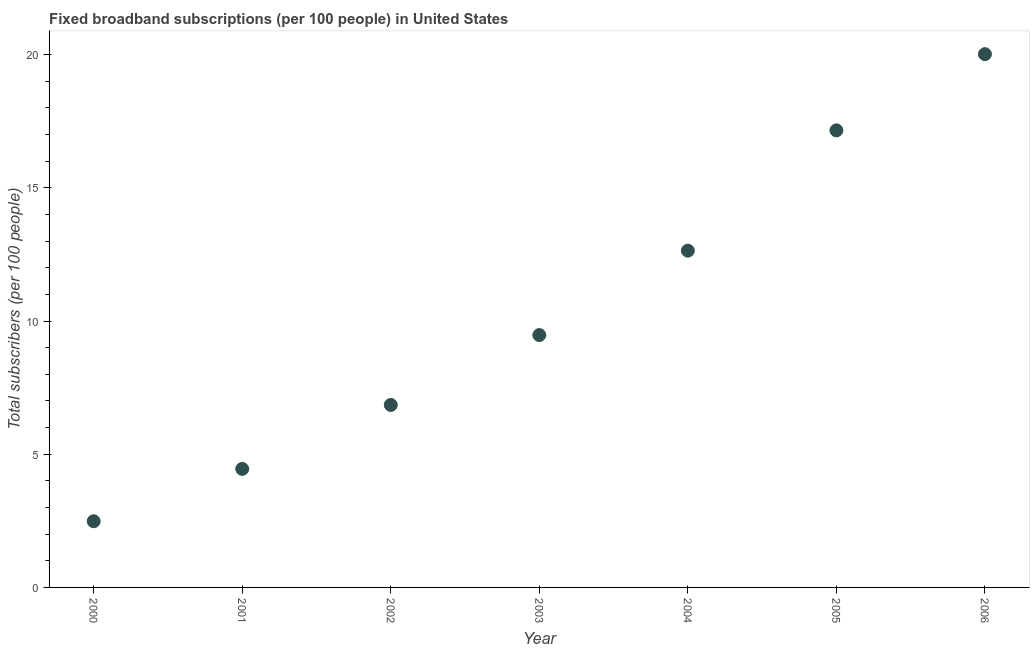What is the total number of fixed broadband subscriptions in 2002?
Offer a very short reply. 6.85. Across all years, what is the maximum total number of fixed broadband subscriptions?
Your answer should be compact. 20.02. Across all years, what is the minimum total number of fixed broadband subscriptions?
Your answer should be very brief. 2.48. What is the sum of the total number of fixed broadband subscriptions?
Give a very brief answer. 73.07. What is the difference between the total number of fixed broadband subscriptions in 2002 and 2005?
Offer a very short reply. -10.31. What is the average total number of fixed broadband subscriptions per year?
Provide a short and direct response. 10.44. What is the median total number of fixed broadband subscriptions?
Provide a short and direct response. 9.47. In how many years, is the total number of fixed broadband subscriptions greater than 10 ?
Keep it short and to the point. 3. What is the ratio of the total number of fixed broadband subscriptions in 2000 to that in 2003?
Make the answer very short. 0.26. Is the difference between the total number of fixed broadband subscriptions in 2004 and 2005 greater than the difference between any two years?
Provide a short and direct response. No. What is the difference between the highest and the second highest total number of fixed broadband subscriptions?
Make the answer very short. 2.86. Is the sum of the total number of fixed broadband subscriptions in 2000 and 2005 greater than the maximum total number of fixed broadband subscriptions across all years?
Make the answer very short. No. What is the difference between the highest and the lowest total number of fixed broadband subscriptions?
Offer a very short reply. 17.53. In how many years, is the total number of fixed broadband subscriptions greater than the average total number of fixed broadband subscriptions taken over all years?
Give a very brief answer. 3. Does the total number of fixed broadband subscriptions monotonically increase over the years?
Keep it short and to the point. Yes. Does the graph contain any zero values?
Your answer should be very brief. No. What is the title of the graph?
Provide a short and direct response. Fixed broadband subscriptions (per 100 people) in United States. What is the label or title of the X-axis?
Your answer should be compact. Year. What is the label or title of the Y-axis?
Offer a very short reply. Total subscribers (per 100 people). What is the Total subscribers (per 100 people) in 2000?
Keep it short and to the point. 2.48. What is the Total subscribers (per 100 people) in 2001?
Provide a succinct answer. 4.45. What is the Total subscribers (per 100 people) in 2002?
Offer a terse response. 6.85. What is the Total subscribers (per 100 people) in 2003?
Give a very brief answer. 9.47. What is the Total subscribers (per 100 people) in 2004?
Your answer should be compact. 12.64. What is the Total subscribers (per 100 people) in 2005?
Make the answer very short. 17.16. What is the Total subscribers (per 100 people) in 2006?
Ensure brevity in your answer.  20.02. What is the difference between the Total subscribers (per 100 people) in 2000 and 2001?
Your answer should be very brief. -1.96. What is the difference between the Total subscribers (per 100 people) in 2000 and 2002?
Keep it short and to the point. -4.37. What is the difference between the Total subscribers (per 100 people) in 2000 and 2003?
Provide a succinct answer. -6.99. What is the difference between the Total subscribers (per 100 people) in 2000 and 2004?
Your answer should be very brief. -10.16. What is the difference between the Total subscribers (per 100 people) in 2000 and 2005?
Your answer should be compact. -14.67. What is the difference between the Total subscribers (per 100 people) in 2000 and 2006?
Ensure brevity in your answer.  -17.53. What is the difference between the Total subscribers (per 100 people) in 2001 and 2002?
Offer a very short reply. -2.4. What is the difference between the Total subscribers (per 100 people) in 2001 and 2003?
Your answer should be compact. -5.02. What is the difference between the Total subscribers (per 100 people) in 2001 and 2004?
Your answer should be compact. -8.19. What is the difference between the Total subscribers (per 100 people) in 2001 and 2005?
Make the answer very short. -12.71. What is the difference between the Total subscribers (per 100 people) in 2001 and 2006?
Ensure brevity in your answer.  -15.57. What is the difference between the Total subscribers (per 100 people) in 2002 and 2003?
Offer a terse response. -2.62. What is the difference between the Total subscribers (per 100 people) in 2002 and 2004?
Make the answer very short. -5.79. What is the difference between the Total subscribers (per 100 people) in 2002 and 2005?
Your answer should be very brief. -10.31. What is the difference between the Total subscribers (per 100 people) in 2002 and 2006?
Your answer should be very brief. -13.17. What is the difference between the Total subscribers (per 100 people) in 2003 and 2004?
Your answer should be very brief. -3.17. What is the difference between the Total subscribers (per 100 people) in 2003 and 2005?
Offer a terse response. -7.68. What is the difference between the Total subscribers (per 100 people) in 2003 and 2006?
Your answer should be compact. -10.54. What is the difference between the Total subscribers (per 100 people) in 2004 and 2005?
Your response must be concise. -4.52. What is the difference between the Total subscribers (per 100 people) in 2004 and 2006?
Provide a succinct answer. -7.38. What is the difference between the Total subscribers (per 100 people) in 2005 and 2006?
Your answer should be very brief. -2.86. What is the ratio of the Total subscribers (per 100 people) in 2000 to that in 2001?
Keep it short and to the point. 0.56. What is the ratio of the Total subscribers (per 100 people) in 2000 to that in 2002?
Give a very brief answer. 0.36. What is the ratio of the Total subscribers (per 100 people) in 2000 to that in 2003?
Your response must be concise. 0.26. What is the ratio of the Total subscribers (per 100 people) in 2000 to that in 2004?
Your answer should be compact. 0.2. What is the ratio of the Total subscribers (per 100 people) in 2000 to that in 2005?
Keep it short and to the point. 0.14. What is the ratio of the Total subscribers (per 100 people) in 2000 to that in 2006?
Offer a very short reply. 0.12. What is the ratio of the Total subscribers (per 100 people) in 2001 to that in 2002?
Give a very brief answer. 0.65. What is the ratio of the Total subscribers (per 100 people) in 2001 to that in 2003?
Make the answer very short. 0.47. What is the ratio of the Total subscribers (per 100 people) in 2001 to that in 2004?
Ensure brevity in your answer.  0.35. What is the ratio of the Total subscribers (per 100 people) in 2001 to that in 2005?
Give a very brief answer. 0.26. What is the ratio of the Total subscribers (per 100 people) in 2001 to that in 2006?
Offer a very short reply. 0.22. What is the ratio of the Total subscribers (per 100 people) in 2002 to that in 2003?
Your answer should be very brief. 0.72. What is the ratio of the Total subscribers (per 100 people) in 2002 to that in 2004?
Keep it short and to the point. 0.54. What is the ratio of the Total subscribers (per 100 people) in 2002 to that in 2005?
Offer a very short reply. 0.4. What is the ratio of the Total subscribers (per 100 people) in 2002 to that in 2006?
Make the answer very short. 0.34. What is the ratio of the Total subscribers (per 100 people) in 2003 to that in 2004?
Your answer should be very brief. 0.75. What is the ratio of the Total subscribers (per 100 people) in 2003 to that in 2005?
Your response must be concise. 0.55. What is the ratio of the Total subscribers (per 100 people) in 2003 to that in 2006?
Your answer should be compact. 0.47. What is the ratio of the Total subscribers (per 100 people) in 2004 to that in 2005?
Give a very brief answer. 0.74. What is the ratio of the Total subscribers (per 100 people) in 2004 to that in 2006?
Your answer should be compact. 0.63. What is the ratio of the Total subscribers (per 100 people) in 2005 to that in 2006?
Offer a terse response. 0.86. 